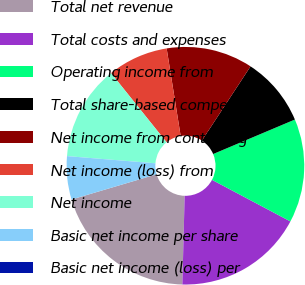Convert chart. <chart><loc_0><loc_0><loc_500><loc_500><pie_chart><fcel>Total net revenue<fcel>Total costs and expenses<fcel>Operating income from<fcel>Total share-based compensation<fcel>Net income from continuing<fcel>Net income (loss) from<fcel>Net income<fcel>Basic net income per share<fcel>Basic net income (loss) per<nl><fcel>20.0%<fcel>17.65%<fcel>14.12%<fcel>9.41%<fcel>11.76%<fcel>8.24%<fcel>12.94%<fcel>5.88%<fcel>0.0%<nl></chart> 